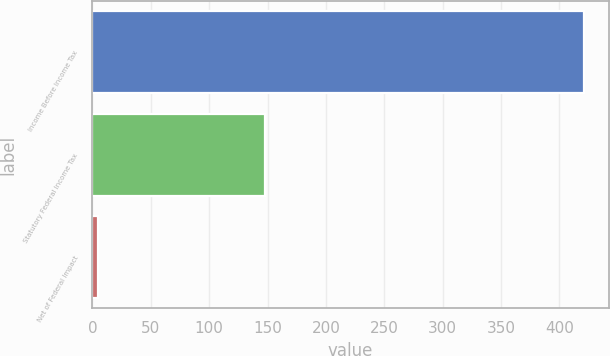<chart> <loc_0><loc_0><loc_500><loc_500><bar_chart><fcel>Income Before Income Tax<fcel>Statutory Federal Income Tax<fcel>Net of Federal Impact<nl><fcel>421.1<fcel>147.4<fcel>5<nl></chart> 